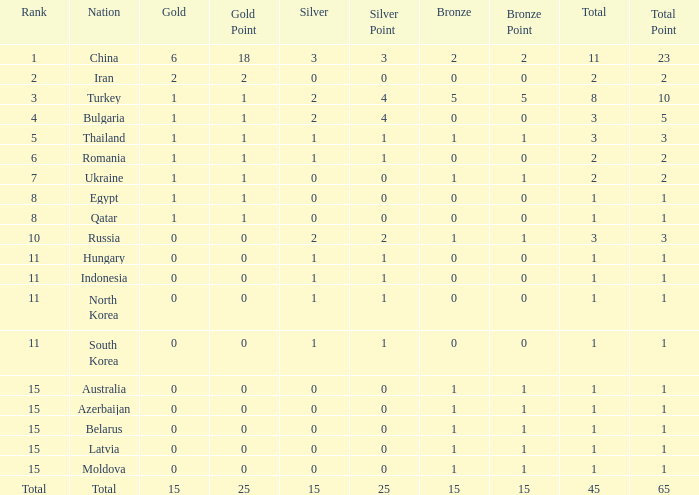What is the sum of the bronze medals of the nation with less than 0 silvers? None. 